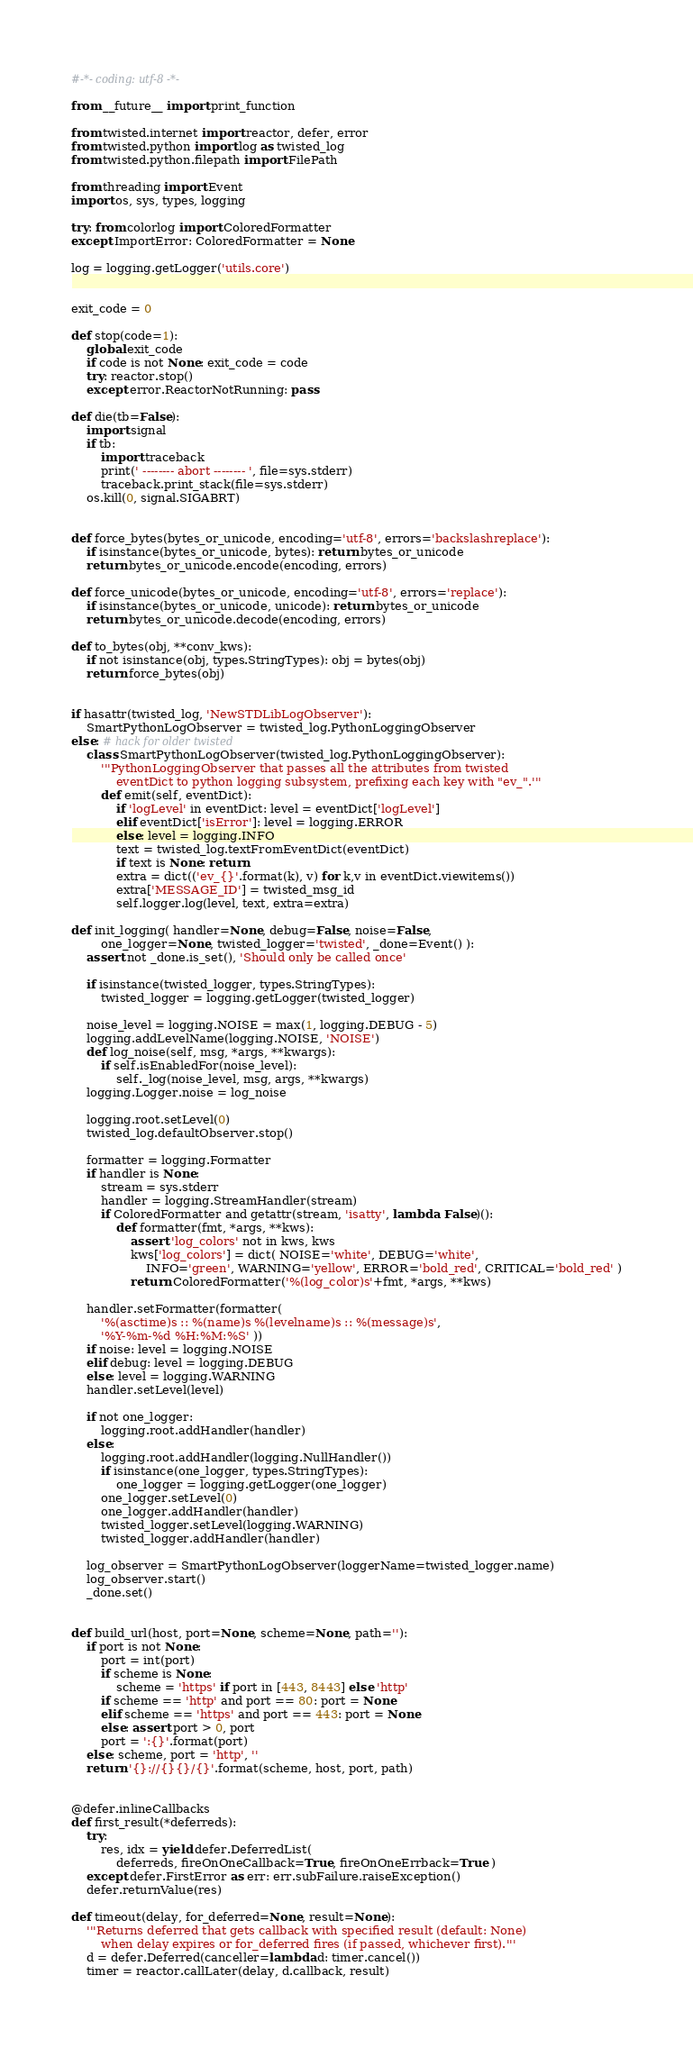Convert code to text. <code><loc_0><loc_0><loc_500><loc_500><_Python_>#-*- coding: utf-8 -*-

from __future__ import print_function

from twisted.internet import reactor, defer, error
from twisted.python import log as twisted_log
from twisted.python.filepath import FilePath

from threading import Event
import os, sys, types, logging

try: from colorlog import ColoredFormatter
except ImportError: ColoredFormatter = None

log = logging.getLogger('utils.core')


exit_code = 0

def stop(code=1):
	global exit_code
	if code is not None: exit_code = code
	try: reactor.stop()
	except error.ReactorNotRunning: pass

def die(tb=False):
	import signal
	if tb:
		import traceback
		print(' -------- abort -------- ', file=sys.stderr)
		traceback.print_stack(file=sys.stderr)
	os.kill(0, signal.SIGABRT)


def force_bytes(bytes_or_unicode, encoding='utf-8', errors='backslashreplace'):
	if isinstance(bytes_or_unicode, bytes): return bytes_or_unicode
	return bytes_or_unicode.encode(encoding, errors)

def force_unicode(bytes_or_unicode, encoding='utf-8', errors='replace'):
	if isinstance(bytes_or_unicode, unicode): return bytes_or_unicode
	return bytes_or_unicode.decode(encoding, errors)

def to_bytes(obj, **conv_kws):
	if not isinstance(obj, types.StringTypes): obj = bytes(obj)
	return force_bytes(obj)


if hasattr(twisted_log, 'NewSTDLibLogObserver'):
	SmartPythonLogObserver = twisted_log.PythonLoggingObserver
else: # hack for older twisted
	class SmartPythonLogObserver(twisted_log.PythonLoggingObserver):
		'''PythonLoggingObserver that passes all the attributes from twisted
			eventDict to python logging subsystem, prefixing each key with "ev_".'''
		def emit(self, eventDict):
			if 'logLevel' in eventDict: level = eventDict['logLevel']
			elif eventDict['isError']: level = logging.ERROR
			else: level = logging.INFO
			text = twisted_log.textFromEventDict(eventDict)
			if text is None: return
			extra = dict(('ev_{}'.format(k), v) for k,v in eventDict.viewitems())
			extra['MESSAGE_ID'] = twisted_msg_id
			self.logger.log(level, text, extra=extra)

def init_logging( handler=None, debug=False, noise=False,
		one_logger=None, twisted_logger='twisted', _done=Event() ):
	assert not _done.is_set(), 'Should only be called once'

	if isinstance(twisted_logger, types.StringTypes):
		twisted_logger = logging.getLogger(twisted_logger)

	noise_level = logging.NOISE = max(1, logging.DEBUG - 5)
	logging.addLevelName(logging.NOISE, 'NOISE')
	def log_noise(self, msg, *args, **kwargs):
		if self.isEnabledFor(noise_level):
			self._log(noise_level, msg, args, **kwargs)
	logging.Logger.noise = log_noise

	logging.root.setLevel(0)
	twisted_log.defaultObserver.stop()

	formatter = logging.Formatter
	if handler is None:
		stream = sys.stderr
		handler = logging.StreamHandler(stream)
		if ColoredFormatter and getattr(stream, 'isatty', lambda: False)():
			def formatter(fmt, *args, **kws):
				assert 'log_colors' not in kws, kws
				kws['log_colors'] = dict( NOISE='white', DEBUG='white',
					INFO='green', WARNING='yellow', ERROR='bold_red', CRITICAL='bold_red' )
				return ColoredFormatter('%(log_color)s'+fmt, *args, **kws)

	handler.setFormatter(formatter(
		'%(asctime)s :: %(name)s %(levelname)s :: %(message)s',
		'%Y-%m-%d %H:%M:%S' ))
	if noise: level = logging.NOISE
	elif debug: level = logging.DEBUG
	else: level = logging.WARNING
	handler.setLevel(level)

	if not one_logger:
		logging.root.addHandler(handler)
	else:
		logging.root.addHandler(logging.NullHandler())
		if isinstance(one_logger, types.StringTypes):
			one_logger = logging.getLogger(one_logger)
		one_logger.setLevel(0)
		one_logger.addHandler(handler)
		twisted_logger.setLevel(logging.WARNING)
		twisted_logger.addHandler(handler)

	log_observer = SmartPythonLogObserver(loggerName=twisted_logger.name)
	log_observer.start()
	_done.set()


def build_url(host, port=None, scheme=None, path=''):
	if port is not None:
		port = int(port)
		if scheme is None:
			scheme = 'https' if port in [443, 8443] else 'http'
		if scheme == 'http' and port == 80: port = None
		elif scheme == 'https' and port == 443: port = None
		else: assert port > 0, port
		port = ':{}'.format(port)
	else: scheme, port = 'http', ''
	return '{}://{}{}/{}'.format(scheme, host, port, path)


@defer.inlineCallbacks
def first_result(*deferreds):
	try:
		res, idx = yield defer.DeferredList(
			deferreds, fireOnOneCallback=True, fireOnOneErrback=True )
	except defer.FirstError as err: err.subFailure.raiseException()
	defer.returnValue(res)

def timeout(delay, for_deferred=None, result=None):
	'''Returns deferred that gets callback with specified result (default: None)
		when delay expires or for_deferred fires (if passed, whichever first).'''
	d = defer.Deferred(canceller=lambda d: timer.cancel())
	timer = reactor.callLater(delay, d.callback, result)</code> 